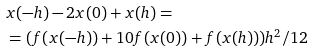Convert formula to latex. <formula><loc_0><loc_0><loc_500><loc_500>& x ( - h ) - 2 x ( 0 ) + x ( h ) = \\ & = ( f ( x ( - h ) ) + 1 0 f ( x ( 0 ) ) + f ( x ( h ) ) ) h ^ { 2 } / 1 2</formula> 